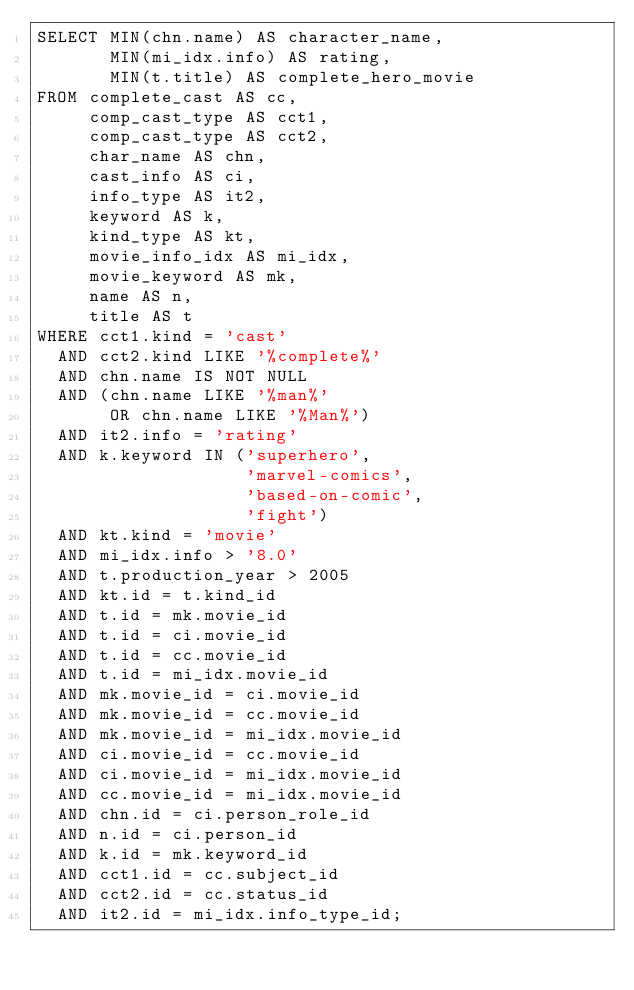<code> <loc_0><loc_0><loc_500><loc_500><_SQL_>SELECT MIN(chn.name) AS character_name,
       MIN(mi_idx.info) AS rating,
       MIN(t.title) AS complete_hero_movie
FROM complete_cast AS cc,
     comp_cast_type AS cct1,
     comp_cast_type AS cct2,
     char_name AS chn,
     cast_info AS ci,
     info_type AS it2,
     keyword AS k,
     kind_type AS kt,
     movie_info_idx AS mi_idx,
     movie_keyword AS mk,
     name AS n,
     title AS t
WHERE cct1.kind = 'cast'
  AND cct2.kind LIKE '%complete%'
  AND chn.name IS NOT NULL
  AND (chn.name LIKE '%man%'
       OR chn.name LIKE '%Man%')
  AND it2.info = 'rating'
  AND k.keyword IN ('superhero',
                    'marvel-comics',
                    'based-on-comic',
                    'fight')
  AND kt.kind = 'movie'
  AND mi_idx.info > '8.0'
  AND t.production_year > 2005
  AND kt.id = t.kind_id
  AND t.id = mk.movie_id
  AND t.id = ci.movie_id
  AND t.id = cc.movie_id
  AND t.id = mi_idx.movie_id
  AND mk.movie_id = ci.movie_id
  AND mk.movie_id = cc.movie_id
  AND mk.movie_id = mi_idx.movie_id
  AND ci.movie_id = cc.movie_id
  AND ci.movie_id = mi_idx.movie_id
  AND cc.movie_id = mi_idx.movie_id
  AND chn.id = ci.person_role_id
  AND n.id = ci.person_id
  AND k.id = mk.keyword_id
  AND cct1.id = cc.subject_id
  AND cct2.id = cc.status_id
  AND it2.id = mi_idx.info_type_id;

</code> 